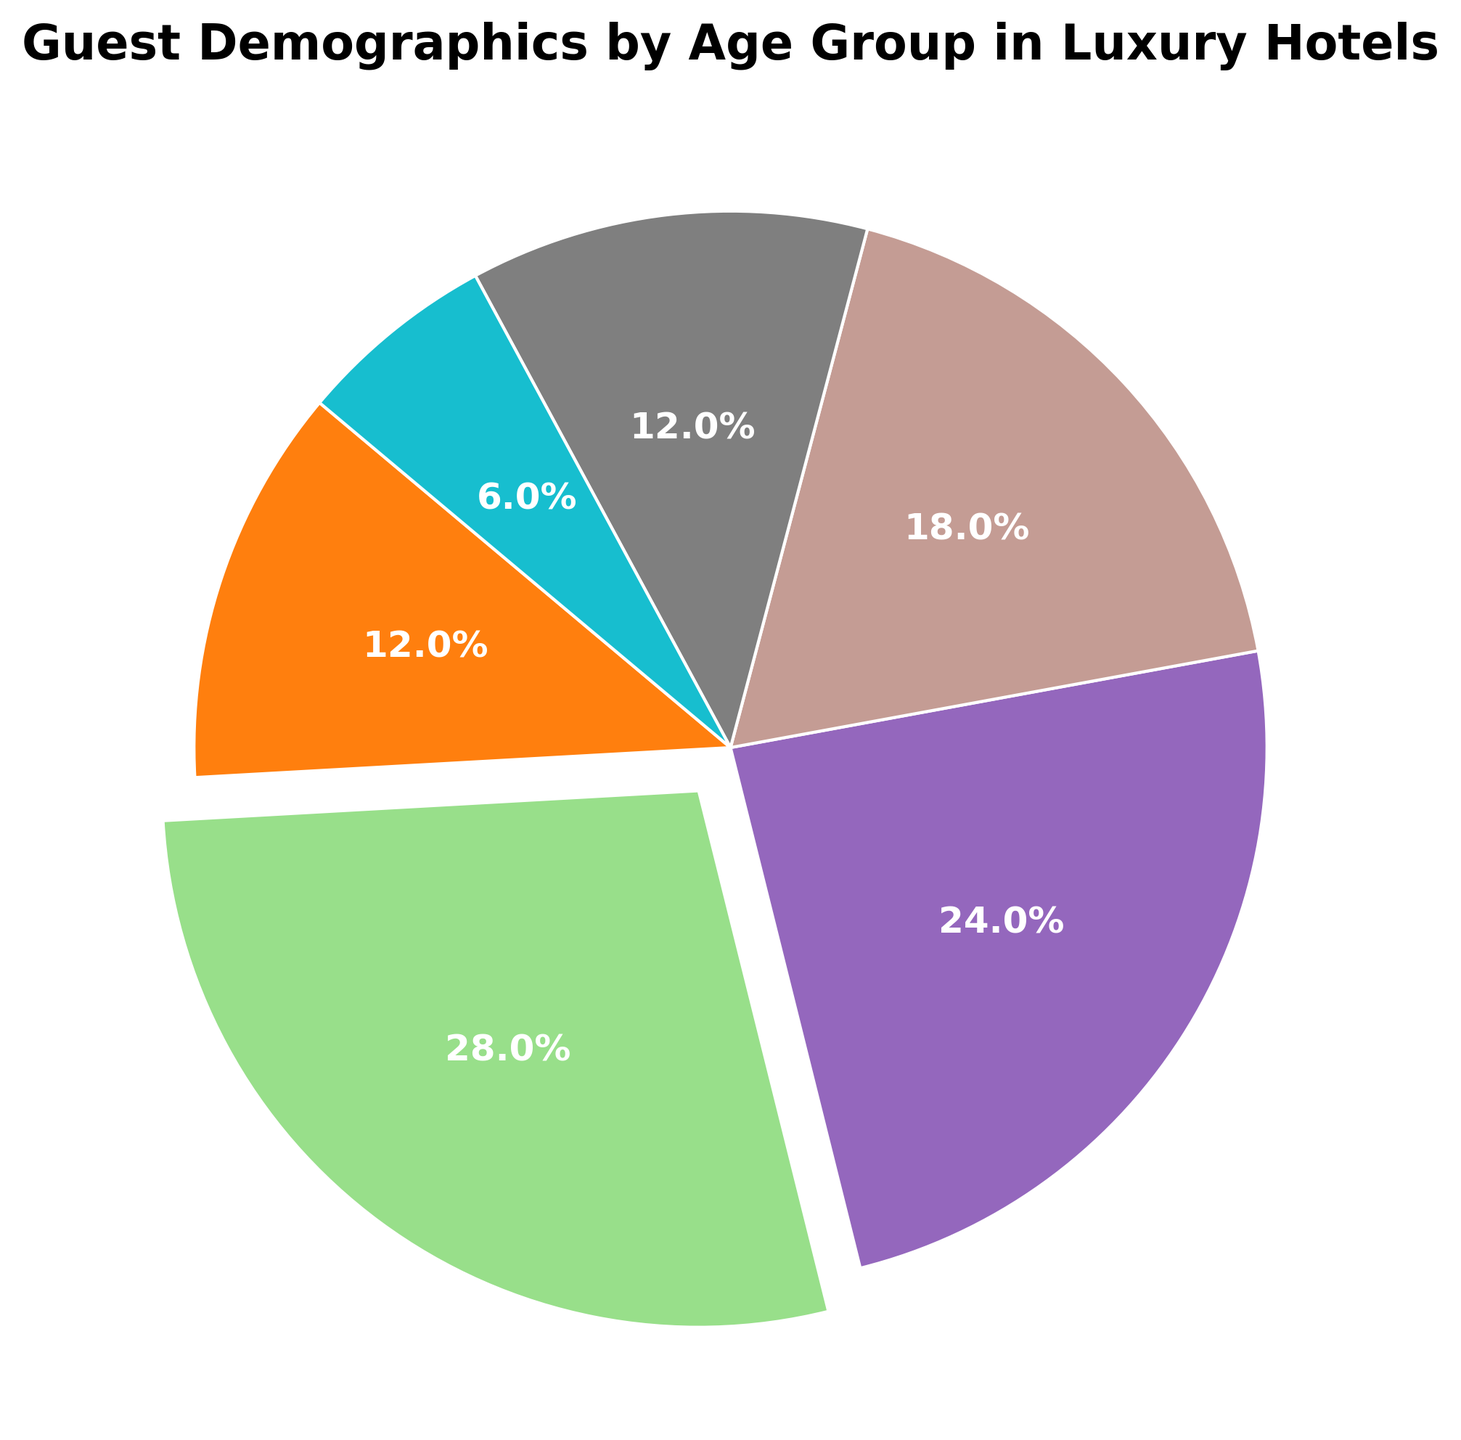What is the age group with the highest percentage of guests in luxury hotels? The figure shows that each age group has a corresponding percentage. The highest percentage, 28%, is seen in the 25-34 age group.
Answer: 25-34 What age group has the lowest percentage of guests in luxury hotels? From the figure, the lowest percentage, 6%, is indicated for the 65 and above age group.
Answer: 65 and above How much higher is the percentage of guests aged 25-34 compared to those aged 55-64? The percentage of guests aged 25-34 is 28%, and that of guests aged 55-64 is 12%. Subtracting 12% from 28% gives 16%.
Answer: 16% Which two age groups combined make up exactly 36% of the guests? The 18-24 age group has 12% and the 55-64 age group also has 12%. Adding these two percentages, 12% + 12% equals 24%, so this is not the right combination. Checking 45-54 (18%) and 65 and above (6%), we get 18% + 6% = 24%, again not the right combination. However, combining 35-44 (24%) and 12% (either from 18-24 or 55-64), the total is 24% + 12% = 36%.
Answer: 35-44 and 18-24 or 35-44 and 55-64 Compare the percentage of guests under 25 to those 65 and above. Guests under 25 (18-24 age group) make up 12%, while those aged 65 and above make up only 6%.
Answer: Higher by 6% Which age group segments are depicted in similarly large wedges in the pie chart? The 25-34 and 35-44 age groups have significant portions; 25-34 at 28% and 35-44 at 24%. Although they are not equal, both are substantially larger segments visually compared to others.
Answer: 25-34 and 35-44 What is the cumulative percentage of guests aged 45 and above? Summing the percentages for 45-54 (18%), 55-64 (12%), and 65 and above (6%) gives 18% + 12% + 6% = 36%.
Answer: 36% Determine how the guest percentage changes from the 35-44 age group to the 45-54 age group. The percentage for the 35-44 age group is 24%, and for the 45-54 age group, it is 18%. The change is a decrease of 6% (24% - 18%).
Answer: Decreases by 6% What is the combined percentage of guests under 35? Adding up the percentages for the 18-24 (12%) and 25-34 (28%) age groups, we get 12% + 28%, which totals 40%.
Answer: 40% 